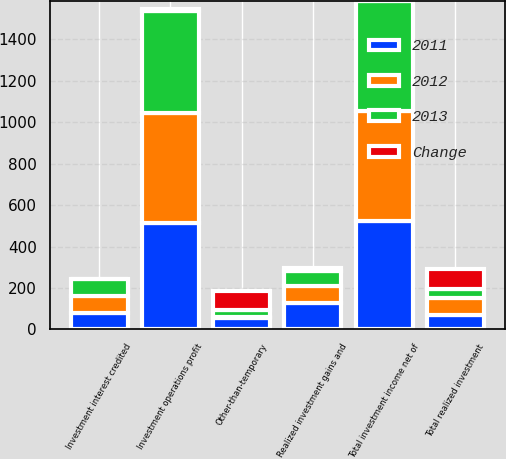<chart> <loc_0><loc_0><loc_500><loc_500><stacked_bar_chart><ecel><fcel>Total investment income net of<fcel>Investment interest credited<fcel>Realized investment gains and<fcel>Other-than-temporary<fcel>Total realized investment<fcel>Investment operations profit<nl><fcel>2012<fcel>529<fcel>80<fcel>82<fcel>2<fcel>83<fcel>532<nl><fcel>2013<fcel>531<fcel>82<fcel>74<fcel>33<fcel>42<fcel>491<nl><fcel>2011<fcel>525<fcel>81<fcel>128<fcel>57<fcel>70<fcel>514<nl><fcel>Change<fcel>0<fcel>2<fcel>11<fcel>94<fcel>98<fcel>8<nl></chart> 